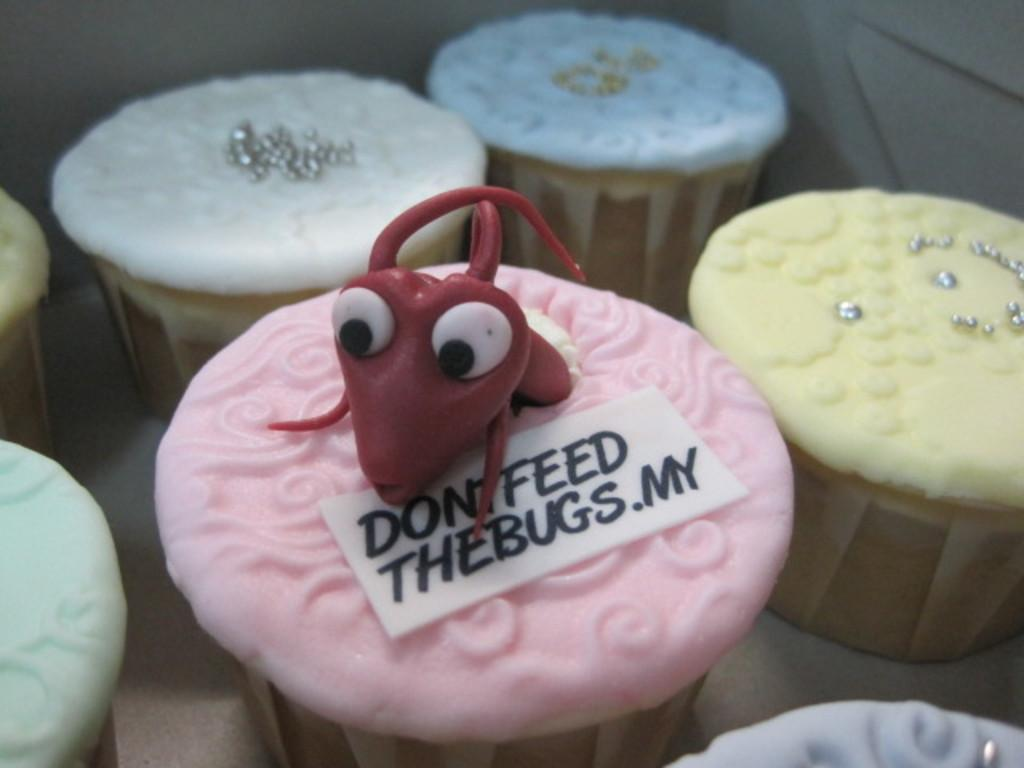What type of dessert is featured in the image? There is a pink color cupcake in the image. What additional features can be seen on the cupcake? The cupcake has text on it and an insect decoration. Are there any other cupcakes visible in the image? Yes, there are more cupcakes visible in the image. Where is the pot located in the image? There is no pot present in the image. What type of hand is visible in the image? There are no hands visible in the image. 